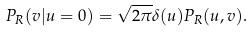<formula> <loc_0><loc_0><loc_500><loc_500>P _ { R } ( v | u = 0 ) = \sqrt { 2 \pi } { \delta } ( u ) P _ { R } ( u , v ) .</formula> 